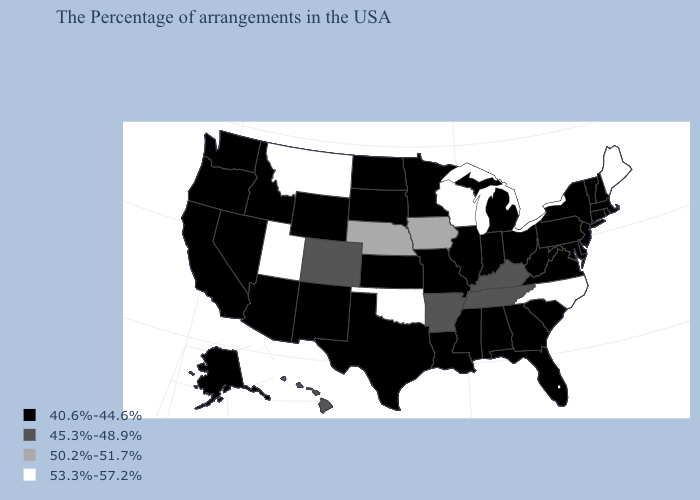Which states hav the highest value in the West?
Give a very brief answer. Utah, Montana. What is the value of Montana?
Quick response, please. 53.3%-57.2%. Among the states that border Colorado , does New Mexico have the lowest value?
Answer briefly. Yes. Name the states that have a value in the range 40.6%-44.6%?
Quick response, please. Massachusetts, Rhode Island, New Hampshire, Vermont, Connecticut, New York, New Jersey, Delaware, Maryland, Pennsylvania, Virginia, South Carolina, West Virginia, Ohio, Florida, Georgia, Michigan, Indiana, Alabama, Illinois, Mississippi, Louisiana, Missouri, Minnesota, Kansas, Texas, South Dakota, North Dakota, Wyoming, New Mexico, Arizona, Idaho, Nevada, California, Washington, Oregon, Alaska. What is the value of Idaho?
Keep it brief. 40.6%-44.6%. Among the states that border Maryland , which have the lowest value?
Write a very short answer. Delaware, Pennsylvania, Virginia, West Virginia. What is the value of Massachusetts?
Concise answer only. 40.6%-44.6%. Is the legend a continuous bar?
Quick response, please. No. Among the states that border West Virginia , which have the lowest value?
Quick response, please. Maryland, Pennsylvania, Virginia, Ohio. Does Wyoming have the same value as Colorado?
Write a very short answer. No. Does North Dakota have the highest value in the USA?
Quick response, please. No. What is the value of Illinois?
Write a very short answer. 40.6%-44.6%. What is the value of Georgia?
Concise answer only. 40.6%-44.6%. Among the states that border Michigan , does Indiana have the highest value?
Keep it brief. No. What is the highest value in states that border Delaware?
Give a very brief answer. 40.6%-44.6%. 